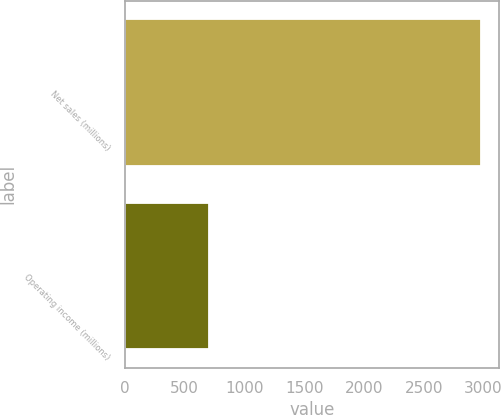Convert chart. <chart><loc_0><loc_0><loc_500><loc_500><bar_chart><fcel>Net sales (millions)<fcel>Operating income (millions)<nl><fcel>2982<fcel>706<nl></chart> 